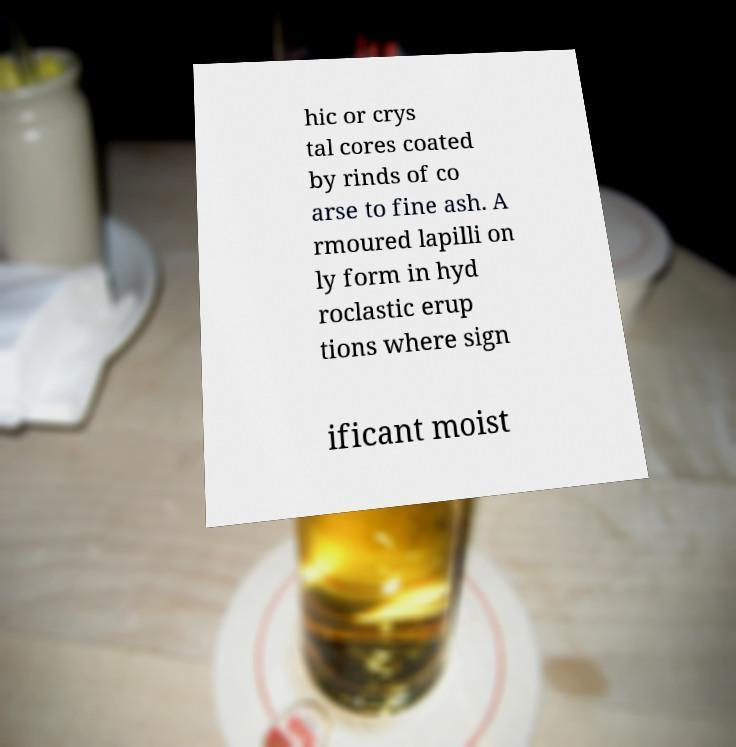Can you accurately transcribe the text from the provided image for me? hic or crys tal cores coated by rinds of co arse to fine ash. A rmoured lapilli on ly form in hyd roclastic erup tions where sign ificant moist 